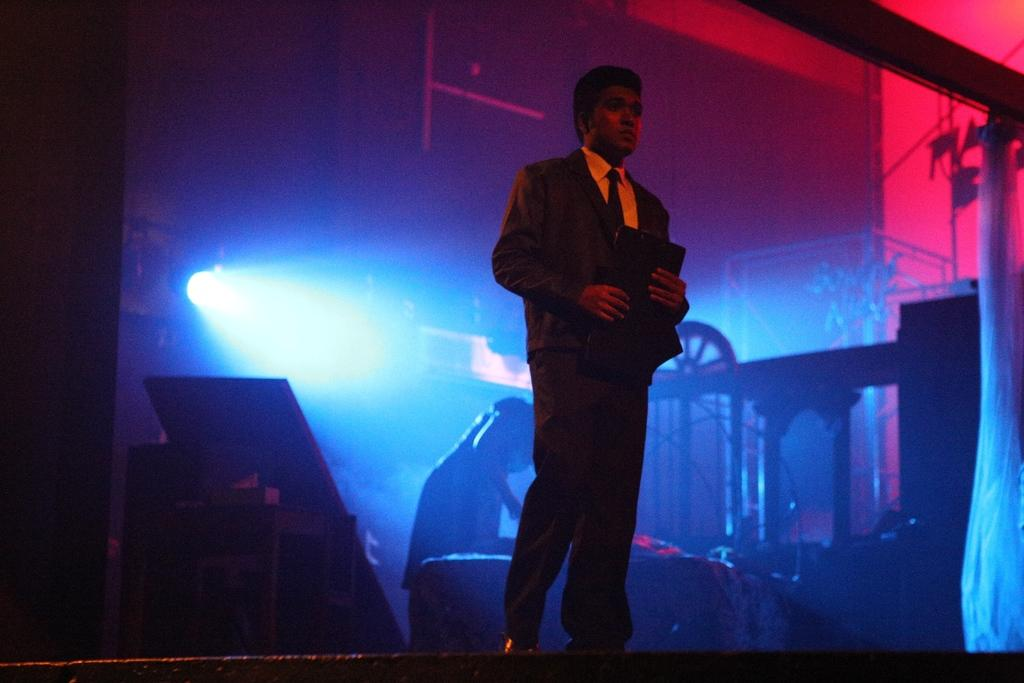What is the person in the image wearing? The person is wearing a suit in the image. What is the person holding in the image? The person is holding an object in the image. What can be seen in the background of the image? There are focusing lights and another person in the background of the image. What type of cover is the person using to express their hate towards the gate in the image? There is no cover, hate, or gate present in the image. 